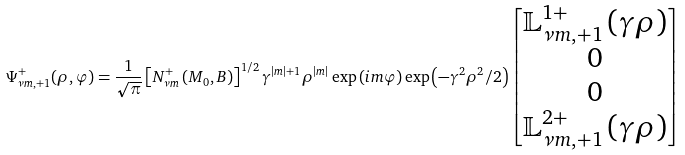Convert formula to latex. <formula><loc_0><loc_0><loc_500><loc_500>\Psi _ { \nu m , + 1 } ^ { + } ( \rho , \varphi ) = \frac { 1 } { \sqrt { \pi } } \left [ N _ { \nu m } ^ { + } \left ( M _ { 0 } , B \right ) \right ] ^ { 1 / 2 } \gamma ^ { \left | m \right | + 1 } \rho ^ { \left | m \right | } \exp \left ( i m \varphi \right ) \exp \left ( - \gamma ^ { 2 } \rho ^ { 2 } / 2 \right ) \begin{bmatrix} \mathbb { L } _ { \nu m , + 1 } ^ { 1 + } \left ( \gamma \rho \right ) \\ 0 \\ 0 \\ \mathbb { L } _ { \nu m , + 1 } ^ { 2 + } \left ( \gamma \rho \right ) \end{bmatrix}</formula> 